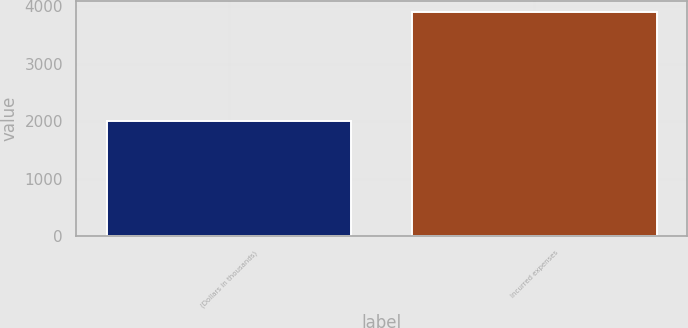<chart> <loc_0><loc_0><loc_500><loc_500><bar_chart><fcel>(Dollars in thousands)<fcel>Incurred expenses<nl><fcel>2013<fcel>3903<nl></chart> 